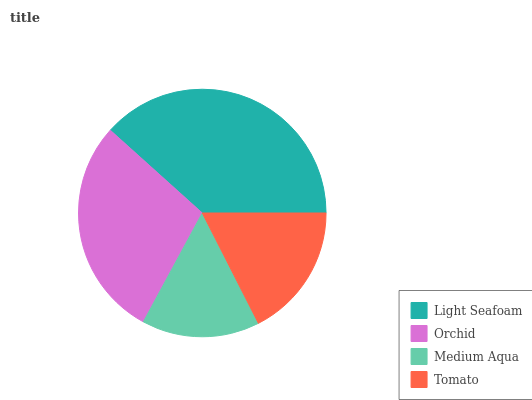Is Medium Aqua the minimum?
Answer yes or no. Yes. Is Light Seafoam the maximum?
Answer yes or no. Yes. Is Orchid the minimum?
Answer yes or no. No. Is Orchid the maximum?
Answer yes or no. No. Is Light Seafoam greater than Orchid?
Answer yes or no. Yes. Is Orchid less than Light Seafoam?
Answer yes or no. Yes. Is Orchid greater than Light Seafoam?
Answer yes or no. No. Is Light Seafoam less than Orchid?
Answer yes or no. No. Is Orchid the high median?
Answer yes or no. Yes. Is Tomato the low median?
Answer yes or no. Yes. Is Light Seafoam the high median?
Answer yes or no. No. Is Orchid the low median?
Answer yes or no. No. 